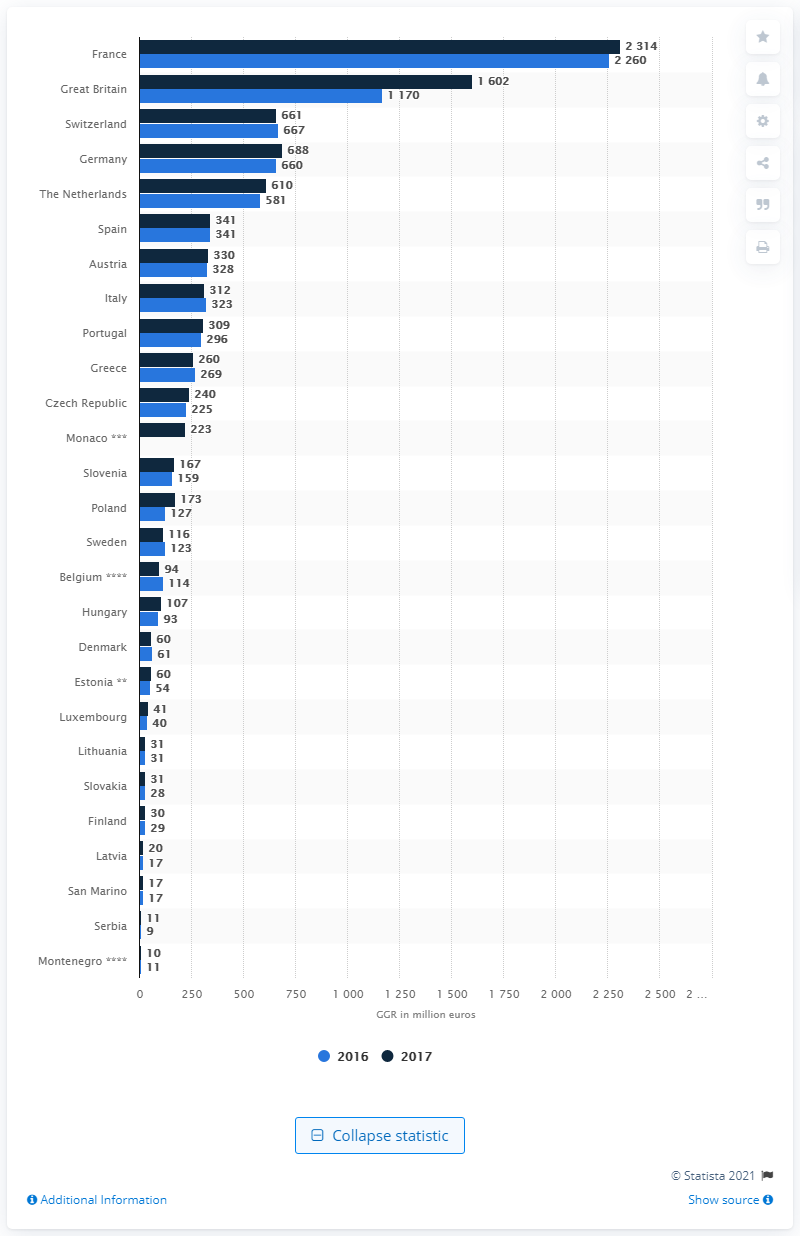Point out several critical features in this image. The Gross Gaming Revenue (GGR) in French casinos in 2017 was 23,140 million euros. 